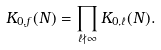<formula> <loc_0><loc_0><loc_500><loc_500>K _ { 0 , f } ( N ) = \prod _ { \ell \nmid \infty } K _ { 0 , \ell } ( N ) .</formula> 